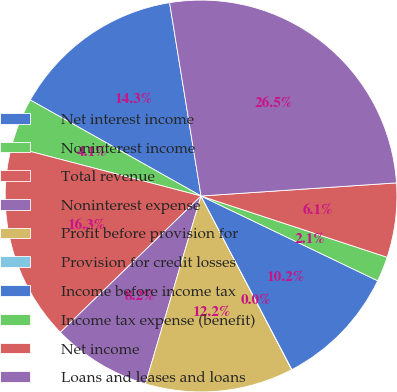Convert chart to OTSL. <chart><loc_0><loc_0><loc_500><loc_500><pie_chart><fcel>Net interest income<fcel>Noninterest income<fcel>Total revenue<fcel>Noninterest expense<fcel>Profit before provision for<fcel>Provision for credit losses<fcel>Income before income tax<fcel>Income tax expense (benefit)<fcel>Net income<fcel>Loans and leases and loans<nl><fcel>14.28%<fcel>4.09%<fcel>16.31%<fcel>8.17%<fcel>12.24%<fcel>0.02%<fcel>10.2%<fcel>2.06%<fcel>6.13%<fcel>26.5%<nl></chart> 